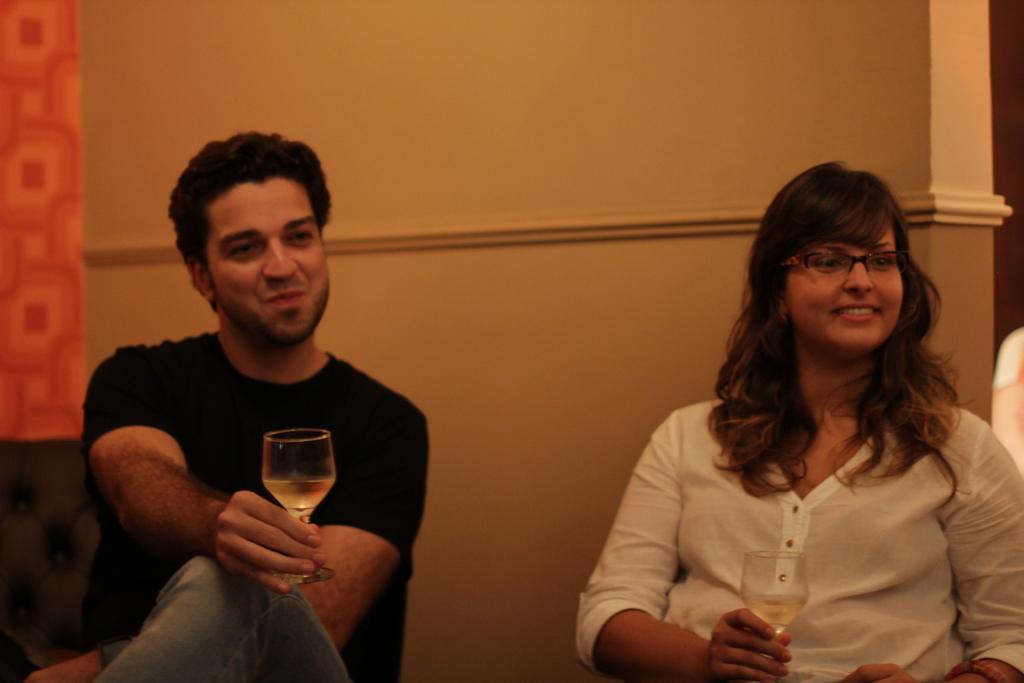Could you give a brief overview of what you see in this image? As we can see in the image, there is a yellow color wall and two persons holding glasses. 